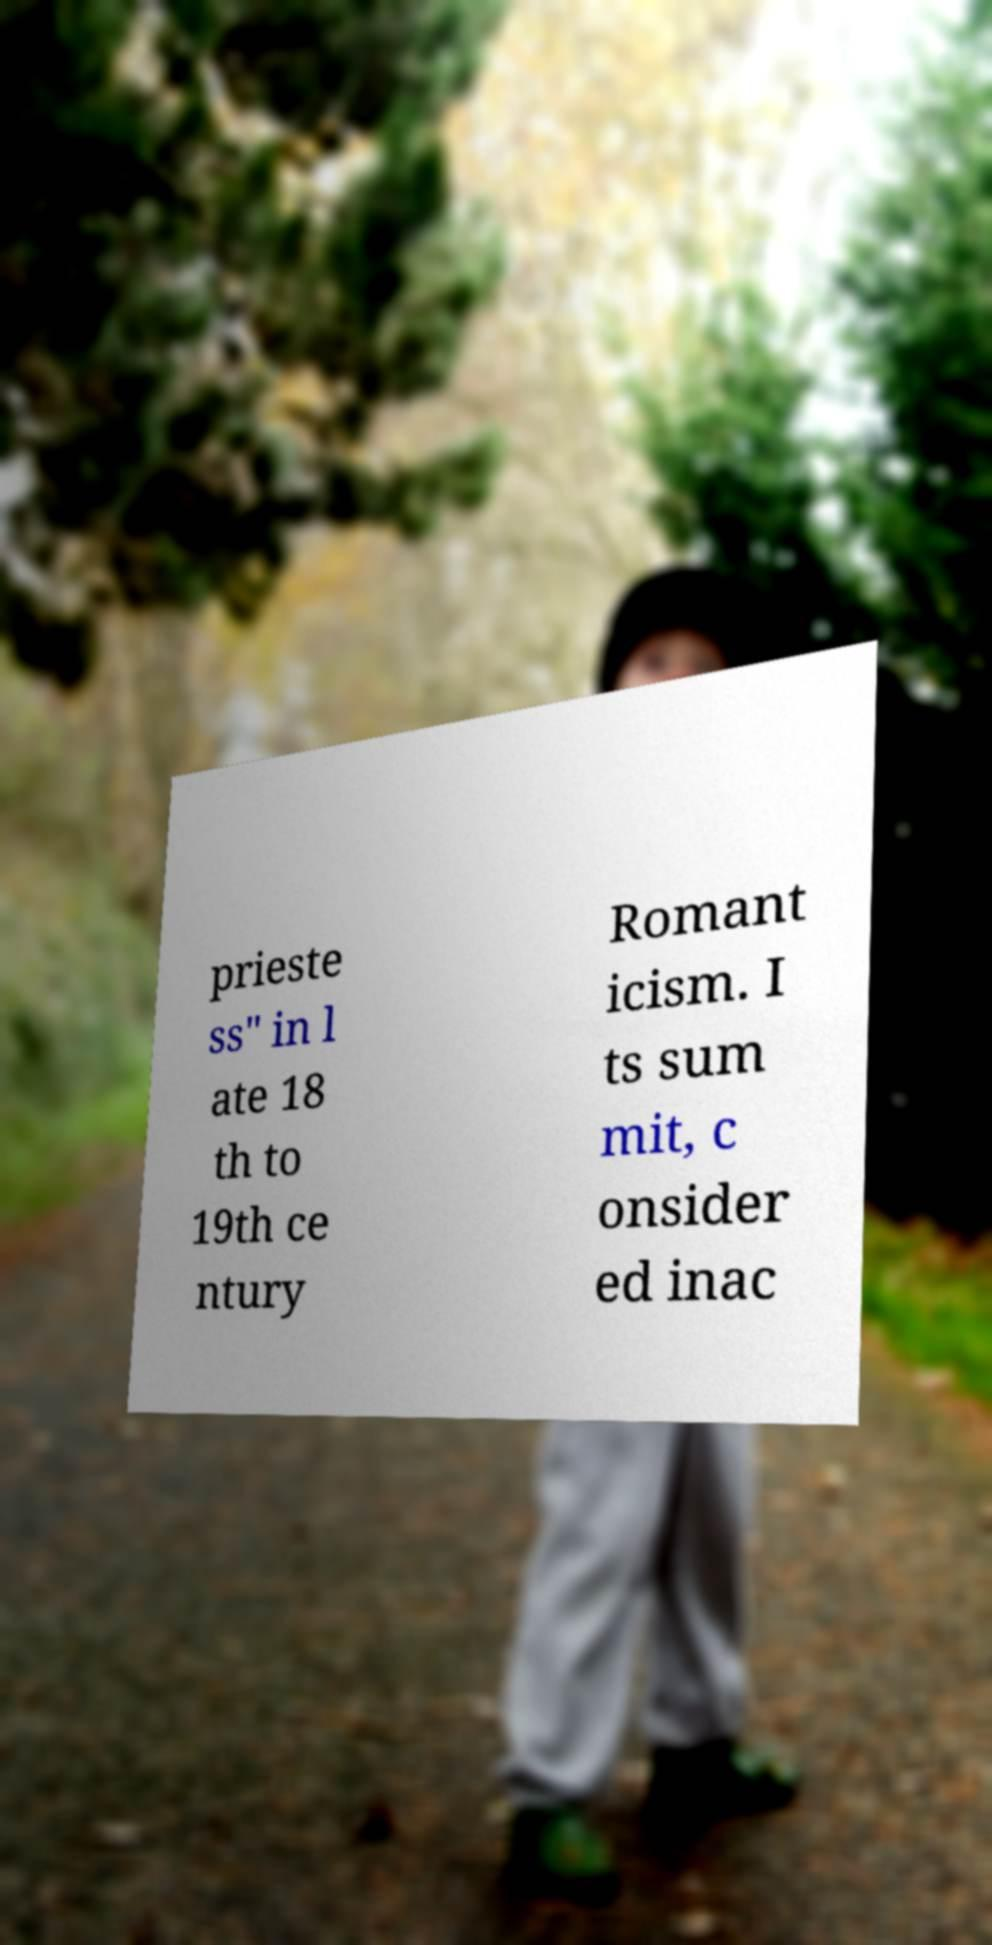Can you read and provide the text displayed in the image?This photo seems to have some interesting text. Can you extract and type it out for me? prieste ss" in l ate 18 th to 19th ce ntury Romant icism. I ts sum mit, c onsider ed inac 